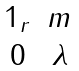Convert formula to latex. <formula><loc_0><loc_0><loc_500><loc_500>\begin{matrix} 1 _ { r } & m \\ 0 & \lambda \end{matrix}</formula> 